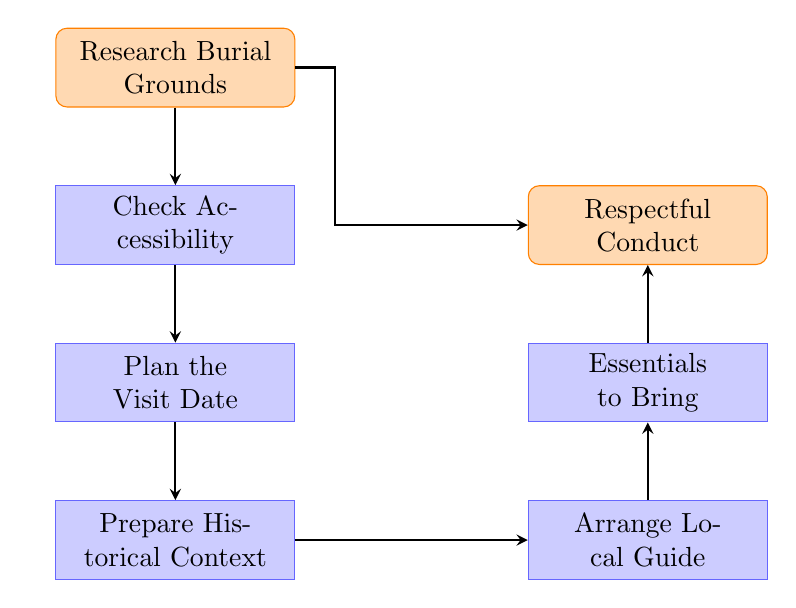What is the first step in the flowchart? The flowchart begins with the step labeled "Research Burial Grounds," which indicates that this is the initial action to undertake.
Answer: Research Burial Grounds How many nodes are in the diagram? The diagram consists of a total of 7 distinct nodes, each representing a different step in planning a visit to a samurai burial ground.
Answer: 7 What step follows "Check Accessibility"? After "Check Accessibility," the next step is "Plan the Visit Date," which continues the process of organizing the visit.
Answer: Plan the Visit Date What is the last step in the diagram? The last step in the flowchart is "Respectful Conduct," completing the process of planning a visit.
Answer: Respectful Conduct Which step is associated with hiring a local guide? "Arrange Local Guide" is the step that relates to hiring a local guide for the visit, as it explicitly mentions these arrangements.
Answer: Arrange Local Guide How is "Respectful Conduct" connected to the other steps? "Respectful Conduct" is connected to the other steps as the last step in the flowchart, ensuring that visitors are aware of cultural etiquette after preparing for the visit.
Answer: Last step What node is to the right of "Prepare Historical Context"? The node that is positioned to the right of "Prepare Historical Context" is "Arrange Local Guide," indicating a parallel consideration in the planning process.
Answer: Arrange Local Guide What essential items should be brought according to the flowchart? The flowchart indicates that "Essentials to Bring" is a necessary step, implying that visitors should pack items such as a camera, water bottle, and comfortable shoes.
Answer: Essentials to Bring What does the loop from "Research Burial Grounds" to "Respectful Conduct" signify? The loop indicates that after researching burial grounds, a visitor could return to consider respectful conduct directly, emphasizing its importance throughout the planning process.
Answer: Importance of Respectful Conduct 